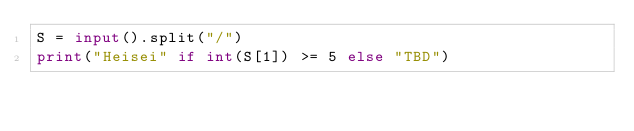Convert code to text. <code><loc_0><loc_0><loc_500><loc_500><_Python_>S = input().split("/")
print("Heisei" if int(S[1]) >= 5 else "TBD")</code> 